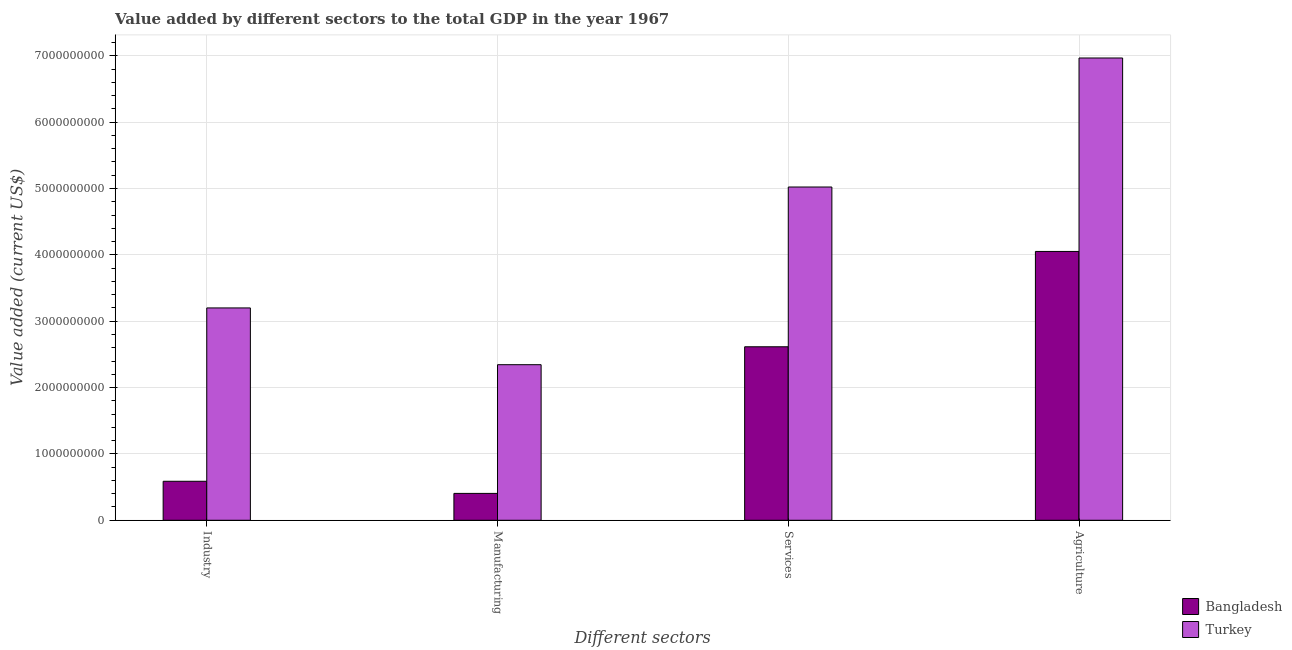How many different coloured bars are there?
Keep it short and to the point. 2. How many groups of bars are there?
Ensure brevity in your answer.  4. Are the number of bars on each tick of the X-axis equal?
Give a very brief answer. Yes. How many bars are there on the 1st tick from the left?
Provide a short and direct response. 2. How many bars are there on the 1st tick from the right?
Provide a succinct answer. 2. What is the label of the 1st group of bars from the left?
Ensure brevity in your answer.  Industry. What is the value added by services sector in Turkey?
Provide a succinct answer. 5.02e+09. Across all countries, what is the maximum value added by industrial sector?
Make the answer very short. 3.20e+09. Across all countries, what is the minimum value added by manufacturing sector?
Your answer should be compact. 4.05e+08. In which country was the value added by agricultural sector maximum?
Your answer should be compact. Turkey. What is the total value added by services sector in the graph?
Offer a very short reply. 7.64e+09. What is the difference between the value added by manufacturing sector in Bangladesh and that in Turkey?
Make the answer very short. -1.94e+09. What is the difference between the value added by agricultural sector in Turkey and the value added by industrial sector in Bangladesh?
Make the answer very short. 6.38e+09. What is the average value added by agricultural sector per country?
Offer a very short reply. 5.51e+09. What is the difference between the value added by agricultural sector and value added by manufacturing sector in Turkey?
Offer a very short reply. 4.62e+09. In how many countries, is the value added by agricultural sector greater than 6800000000 US$?
Make the answer very short. 1. What is the ratio of the value added by manufacturing sector in Bangladesh to that in Turkey?
Give a very brief answer. 0.17. Is the difference between the value added by services sector in Bangladesh and Turkey greater than the difference between the value added by agricultural sector in Bangladesh and Turkey?
Provide a succinct answer. Yes. What is the difference between the highest and the second highest value added by agricultural sector?
Your answer should be compact. 2.92e+09. What is the difference between the highest and the lowest value added by manufacturing sector?
Offer a terse response. 1.94e+09. What does the 1st bar from the left in Manufacturing represents?
Keep it short and to the point. Bangladesh. What does the 1st bar from the right in Services represents?
Your response must be concise. Turkey. Is it the case that in every country, the sum of the value added by industrial sector and value added by manufacturing sector is greater than the value added by services sector?
Your response must be concise. No. How many bars are there?
Provide a succinct answer. 8. Are all the bars in the graph horizontal?
Provide a succinct answer. No. How many countries are there in the graph?
Give a very brief answer. 2. Does the graph contain any zero values?
Ensure brevity in your answer.  No. Where does the legend appear in the graph?
Give a very brief answer. Bottom right. How many legend labels are there?
Offer a terse response. 2. How are the legend labels stacked?
Give a very brief answer. Vertical. What is the title of the graph?
Offer a very short reply. Value added by different sectors to the total GDP in the year 1967. Does "Bangladesh" appear as one of the legend labels in the graph?
Provide a short and direct response. Yes. What is the label or title of the X-axis?
Your answer should be compact. Different sectors. What is the label or title of the Y-axis?
Make the answer very short. Value added (current US$). What is the Value added (current US$) of Bangladesh in Industry?
Make the answer very short. 5.88e+08. What is the Value added (current US$) in Turkey in Industry?
Provide a succinct answer. 3.20e+09. What is the Value added (current US$) in Bangladesh in Manufacturing?
Offer a very short reply. 4.05e+08. What is the Value added (current US$) of Turkey in Manufacturing?
Ensure brevity in your answer.  2.34e+09. What is the Value added (current US$) of Bangladesh in Services?
Offer a terse response. 2.61e+09. What is the Value added (current US$) of Turkey in Services?
Ensure brevity in your answer.  5.02e+09. What is the Value added (current US$) of Bangladesh in Agriculture?
Offer a terse response. 4.05e+09. What is the Value added (current US$) of Turkey in Agriculture?
Provide a short and direct response. 6.97e+09. Across all Different sectors, what is the maximum Value added (current US$) of Bangladesh?
Give a very brief answer. 4.05e+09. Across all Different sectors, what is the maximum Value added (current US$) in Turkey?
Your response must be concise. 6.97e+09. Across all Different sectors, what is the minimum Value added (current US$) of Bangladesh?
Make the answer very short. 4.05e+08. Across all Different sectors, what is the minimum Value added (current US$) of Turkey?
Your response must be concise. 2.34e+09. What is the total Value added (current US$) of Bangladesh in the graph?
Your answer should be very brief. 7.66e+09. What is the total Value added (current US$) in Turkey in the graph?
Your answer should be very brief. 1.75e+1. What is the difference between the Value added (current US$) of Bangladesh in Industry and that in Manufacturing?
Ensure brevity in your answer.  1.83e+08. What is the difference between the Value added (current US$) of Turkey in Industry and that in Manufacturing?
Give a very brief answer. 8.56e+08. What is the difference between the Value added (current US$) in Bangladesh in Industry and that in Services?
Make the answer very short. -2.03e+09. What is the difference between the Value added (current US$) of Turkey in Industry and that in Services?
Your response must be concise. -1.82e+09. What is the difference between the Value added (current US$) of Bangladesh in Industry and that in Agriculture?
Offer a very short reply. -3.46e+09. What is the difference between the Value added (current US$) of Turkey in Industry and that in Agriculture?
Offer a very short reply. -3.77e+09. What is the difference between the Value added (current US$) of Bangladesh in Manufacturing and that in Services?
Keep it short and to the point. -2.21e+09. What is the difference between the Value added (current US$) of Turkey in Manufacturing and that in Services?
Give a very brief answer. -2.68e+09. What is the difference between the Value added (current US$) of Bangladesh in Manufacturing and that in Agriculture?
Your response must be concise. -3.65e+09. What is the difference between the Value added (current US$) in Turkey in Manufacturing and that in Agriculture?
Keep it short and to the point. -4.62e+09. What is the difference between the Value added (current US$) of Bangladesh in Services and that in Agriculture?
Provide a short and direct response. -1.44e+09. What is the difference between the Value added (current US$) of Turkey in Services and that in Agriculture?
Ensure brevity in your answer.  -1.94e+09. What is the difference between the Value added (current US$) of Bangladesh in Industry and the Value added (current US$) of Turkey in Manufacturing?
Offer a very short reply. -1.76e+09. What is the difference between the Value added (current US$) of Bangladesh in Industry and the Value added (current US$) of Turkey in Services?
Ensure brevity in your answer.  -4.43e+09. What is the difference between the Value added (current US$) in Bangladesh in Industry and the Value added (current US$) in Turkey in Agriculture?
Offer a very short reply. -6.38e+09. What is the difference between the Value added (current US$) in Bangladesh in Manufacturing and the Value added (current US$) in Turkey in Services?
Offer a terse response. -4.62e+09. What is the difference between the Value added (current US$) of Bangladesh in Manufacturing and the Value added (current US$) of Turkey in Agriculture?
Your answer should be compact. -6.56e+09. What is the difference between the Value added (current US$) of Bangladesh in Services and the Value added (current US$) of Turkey in Agriculture?
Provide a short and direct response. -4.35e+09. What is the average Value added (current US$) in Bangladesh per Different sectors?
Ensure brevity in your answer.  1.91e+09. What is the average Value added (current US$) of Turkey per Different sectors?
Make the answer very short. 4.38e+09. What is the difference between the Value added (current US$) of Bangladesh and Value added (current US$) of Turkey in Industry?
Give a very brief answer. -2.61e+09. What is the difference between the Value added (current US$) of Bangladesh and Value added (current US$) of Turkey in Manufacturing?
Give a very brief answer. -1.94e+09. What is the difference between the Value added (current US$) in Bangladesh and Value added (current US$) in Turkey in Services?
Provide a short and direct response. -2.41e+09. What is the difference between the Value added (current US$) in Bangladesh and Value added (current US$) in Turkey in Agriculture?
Make the answer very short. -2.92e+09. What is the ratio of the Value added (current US$) in Bangladesh in Industry to that in Manufacturing?
Make the answer very short. 1.45. What is the ratio of the Value added (current US$) of Turkey in Industry to that in Manufacturing?
Make the answer very short. 1.36. What is the ratio of the Value added (current US$) in Bangladesh in Industry to that in Services?
Give a very brief answer. 0.22. What is the ratio of the Value added (current US$) of Turkey in Industry to that in Services?
Your answer should be very brief. 0.64. What is the ratio of the Value added (current US$) in Bangladesh in Industry to that in Agriculture?
Ensure brevity in your answer.  0.15. What is the ratio of the Value added (current US$) in Turkey in Industry to that in Agriculture?
Provide a succinct answer. 0.46. What is the ratio of the Value added (current US$) in Bangladesh in Manufacturing to that in Services?
Provide a succinct answer. 0.15. What is the ratio of the Value added (current US$) in Turkey in Manufacturing to that in Services?
Make the answer very short. 0.47. What is the ratio of the Value added (current US$) of Turkey in Manufacturing to that in Agriculture?
Your response must be concise. 0.34. What is the ratio of the Value added (current US$) of Bangladesh in Services to that in Agriculture?
Ensure brevity in your answer.  0.65. What is the ratio of the Value added (current US$) of Turkey in Services to that in Agriculture?
Provide a succinct answer. 0.72. What is the difference between the highest and the second highest Value added (current US$) in Bangladesh?
Your answer should be very brief. 1.44e+09. What is the difference between the highest and the second highest Value added (current US$) in Turkey?
Keep it short and to the point. 1.94e+09. What is the difference between the highest and the lowest Value added (current US$) in Bangladesh?
Provide a short and direct response. 3.65e+09. What is the difference between the highest and the lowest Value added (current US$) of Turkey?
Your answer should be very brief. 4.62e+09. 